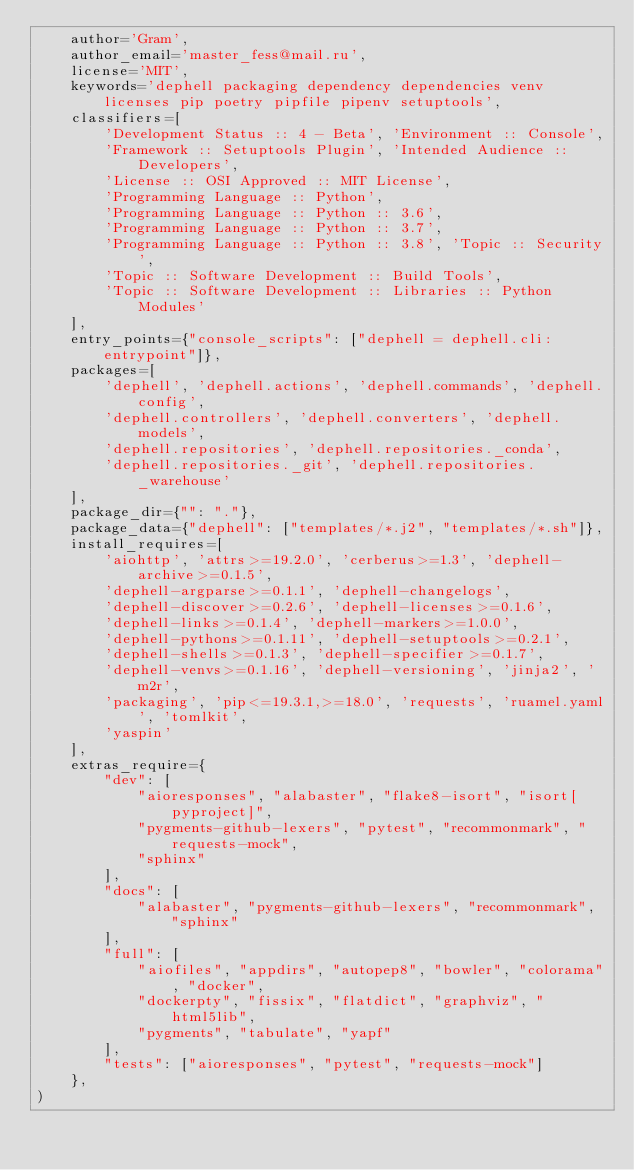Convert code to text. <code><loc_0><loc_0><loc_500><loc_500><_Python_>    author='Gram',
    author_email='master_fess@mail.ru',
    license='MIT',
    keywords='dephell packaging dependency dependencies venv licenses pip poetry pipfile pipenv setuptools',
    classifiers=[
        'Development Status :: 4 - Beta', 'Environment :: Console',
        'Framework :: Setuptools Plugin', 'Intended Audience :: Developers',
        'License :: OSI Approved :: MIT License',
        'Programming Language :: Python',
        'Programming Language :: Python :: 3.6',
        'Programming Language :: Python :: 3.7',
        'Programming Language :: Python :: 3.8', 'Topic :: Security',
        'Topic :: Software Development :: Build Tools',
        'Topic :: Software Development :: Libraries :: Python Modules'
    ],
    entry_points={"console_scripts": ["dephell = dephell.cli:entrypoint"]},
    packages=[
        'dephell', 'dephell.actions', 'dephell.commands', 'dephell.config',
        'dephell.controllers', 'dephell.converters', 'dephell.models',
        'dephell.repositories', 'dephell.repositories._conda',
        'dephell.repositories._git', 'dephell.repositories._warehouse'
    ],
    package_dir={"": "."},
    package_data={"dephell": ["templates/*.j2", "templates/*.sh"]},
    install_requires=[
        'aiohttp', 'attrs>=19.2.0', 'cerberus>=1.3', 'dephell-archive>=0.1.5',
        'dephell-argparse>=0.1.1', 'dephell-changelogs',
        'dephell-discover>=0.2.6', 'dephell-licenses>=0.1.6',
        'dephell-links>=0.1.4', 'dephell-markers>=1.0.0',
        'dephell-pythons>=0.1.11', 'dephell-setuptools>=0.2.1',
        'dephell-shells>=0.1.3', 'dephell-specifier>=0.1.7',
        'dephell-venvs>=0.1.16', 'dephell-versioning', 'jinja2', 'm2r',
        'packaging', 'pip<=19.3.1,>=18.0', 'requests', 'ruamel.yaml', 'tomlkit',
        'yaspin'
    ],
    extras_require={
        "dev": [
            "aioresponses", "alabaster", "flake8-isort", "isort[pyproject]",
            "pygments-github-lexers", "pytest", "recommonmark", "requests-mock",
            "sphinx"
        ],
        "docs": [
            "alabaster", "pygments-github-lexers", "recommonmark", "sphinx"
        ],
        "full": [
            "aiofiles", "appdirs", "autopep8", "bowler", "colorama", "docker",
            "dockerpty", "fissix", "flatdict", "graphviz", "html5lib",
            "pygments", "tabulate", "yapf"
        ],
        "tests": ["aioresponses", "pytest", "requests-mock"]
    },
)
</code> 